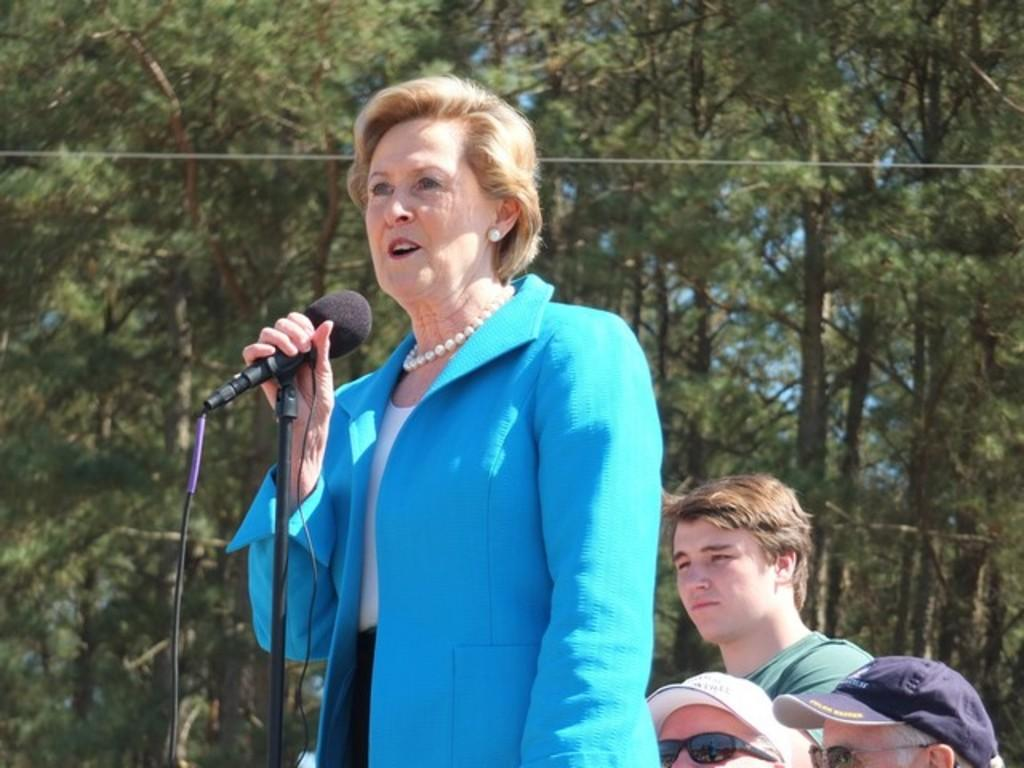What is the main setting of the image? There is an open area in the image. Can you describe the woman in the image? The woman is present in the image, and she is wearing a blue color blazer. What is the woman doing in the image? The woman is speaking through a mic. What can be seen in the background of the image? There are people sitting in the background, big trees are visible, and the sky is visible as well. How far away is the sun from the woman in the image? The sun is not visible in the image, so we cannot determine its distance from the woman. 